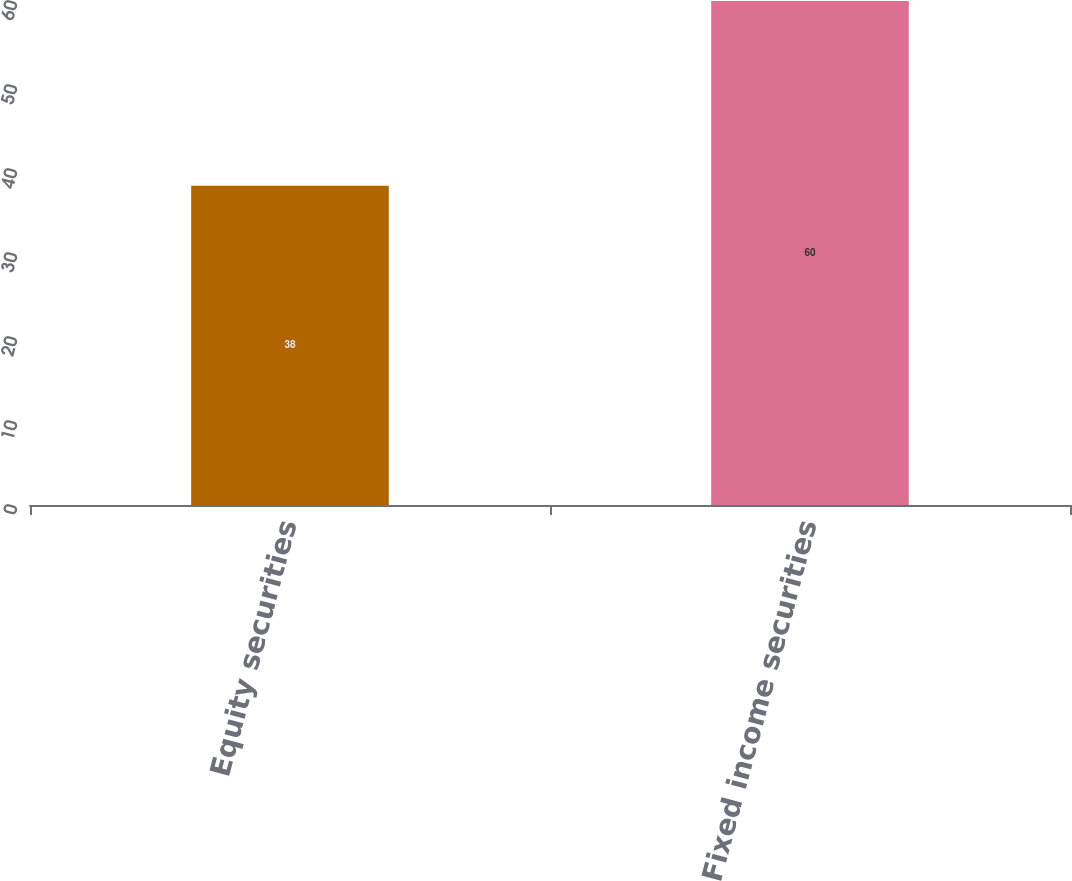Convert chart to OTSL. <chart><loc_0><loc_0><loc_500><loc_500><bar_chart><fcel>Equity securities<fcel>Fixed income securities<nl><fcel>38<fcel>60<nl></chart> 